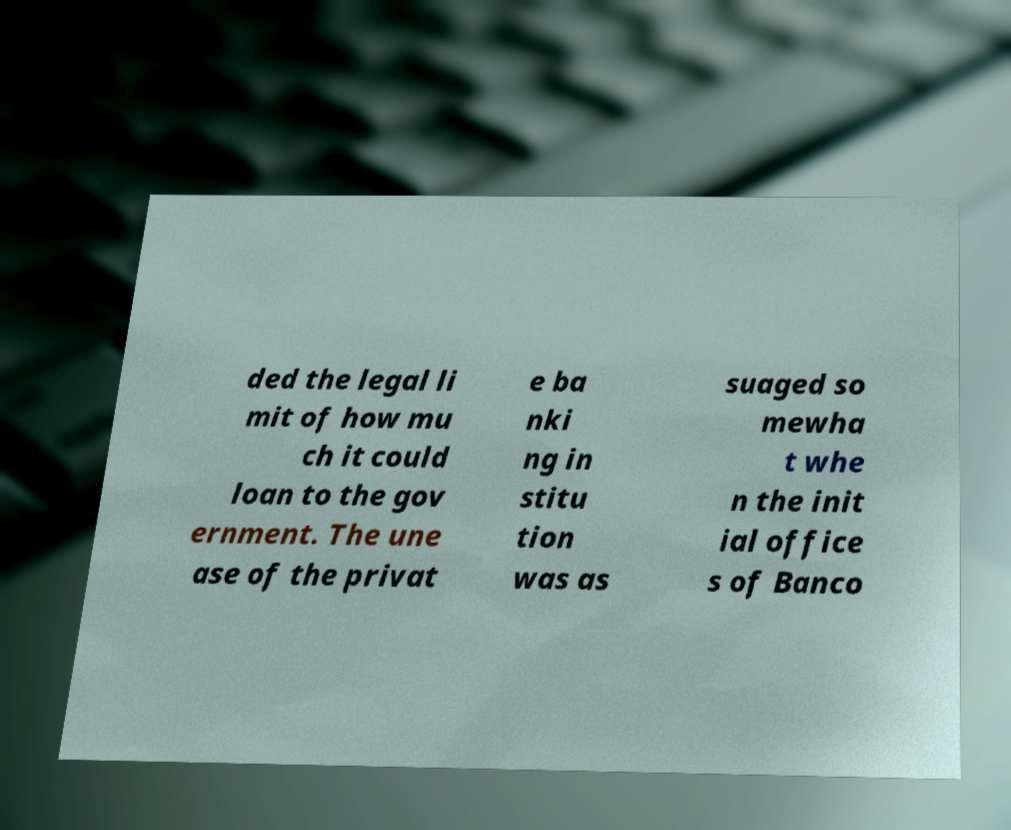Can you read and provide the text displayed in the image?This photo seems to have some interesting text. Can you extract and type it out for me? ded the legal li mit of how mu ch it could loan to the gov ernment. The une ase of the privat e ba nki ng in stitu tion was as suaged so mewha t whe n the init ial office s of Banco 